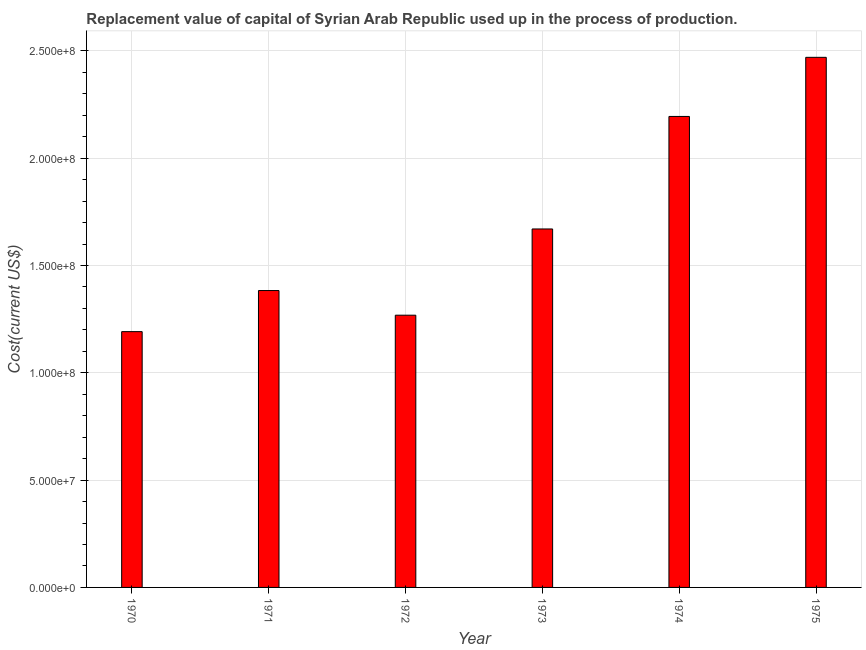Does the graph contain any zero values?
Give a very brief answer. No. Does the graph contain grids?
Provide a short and direct response. Yes. What is the title of the graph?
Provide a succinct answer. Replacement value of capital of Syrian Arab Republic used up in the process of production. What is the label or title of the X-axis?
Keep it short and to the point. Year. What is the label or title of the Y-axis?
Offer a very short reply. Cost(current US$). What is the consumption of fixed capital in 1972?
Make the answer very short. 1.27e+08. Across all years, what is the maximum consumption of fixed capital?
Your response must be concise. 2.47e+08. Across all years, what is the minimum consumption of fixed capital?
Provide a short and direct response. 1.19e+08. In which year was the consumption of fixed capital maximum?
Ensure brevity in your answer.  1975. In which year was the consumption of fixed capital minimum?
Offer a very short reply. 1970. What is the sum of the consumption of fixed capital?
Provide a succinct answer. 1.02e+09. What is the difference between the consumption of fixed capital in 1972 and 1975?
Provide a short and direct response. -1.20e+08. What is the average consumption of fixed capital per year?
Your answer should be very brief. 1.70e+08. What is the median consumption of fixed capital?
Your response must be concise. 1.53e+08. In how many years, is the consumption of fixed capital greater than 130000000 US$?
Offer a very short reply. 4. Do a majority of the years between 1975 and 1972 (inclusive) have consumption of fixed capital greater than 240000000 US$?
Keep it short and to the point. Yes. What is the ratio of the consumption of fixed capital in 1973 to that in 1975?
Ensure brevity in your answer.  0.68. Is the consumption of fixed capital in 1971 less than that in 1975?
Keep it short and to the point. Yes. What is the difference between the highest and the second highest consumption of fixed capital?
Keep it short and to the point. 2.75e+07. What is the difference between the highest and the lowest consumption of fixed capital?
Make the answer very short. 1.28e+08. In how many years, is the consumption of fixed capital greater than the average consumption of fixed capital taken over all years?
Provide a short and direct response. 2. How many bars are there?
Provide a succinct answer. 6. How many years are there in the graph?
Offer a very short reply. 6. What is the difference between two consecutive major ticks on the Y-axis?
Your answer should be compact. 5.00e+07. What is the Cost(current US$) of 1970?
Ensure brevity in your answer.  1.19e+08. What is the Cost(current US$) in 1971?
Your answer should be very brief. 1.38e+08. What is the Cost(current US$) of 1972?
Provide a succinct answer. 1.27e+08. What is the Cost(current US$) in 1973?
Your answer should be very brief. 1.67e+08. What is the Cost(current US$) in 1974?
Ensure brevity in your answer.  2.19e+08. What is the Cost(current US$) of 1975?
Provide a succinct answer. 2.47e+08. What is the difference between the Cost(current US$) in 1970 and 1971?
Provide a succinct answer. -1.91e+07. What is the difference between the Cost(current US$) in 1970 and 1972?
Give a very brief answer. -7.66e+06. What is the difference between the Cost(current US$) in 1970 and 1973?
Offer a very short reply. -4.78e+07. What is the difference between the Cost(current US$) in 1970 and 1974?
Your answer should be compact. -1.00e+08. What is the difference between the Cost(current US$) in 1970 and 1975?
Offer a terse response. -1.28e+08. What is the difference between the Cost(current US$) in 1971 and 1972?
Keep it short and to the point. 1.15e+07. What is the difference between the Cost(current US$) in 1971 and 1973?
Make the answer very short. -2.87e+07. What is the difference between the Cost(current US$) in 1971 and 1974?
Make the answer very short. -8.11e+07. What is the difference between the Cost(current US$) in 1971 and 1975?
Ensure brevity in your answer.  -1.09e+08. What is the difference between the Cost(current US$) in 1972 and 1973?
Make the answer very short. -4.02e+07. What is the difference between the Cost(current US$) in 1972 and 1974?
Your answer should be compact. -9.26e+07. What is the difference between the Cost(current US$) in 1972 and 1975?
Your answer should be very brief. -1.20e+08. What is the difference between the Cost(current US$) in 1973 and 1974?
Provide a succinct answer. -5.24e+07. What is the difference between the Cost(current US$) in 1973 and 1975?
Your response must be concise. -8.00e+07. What is the difference between the Cost(current US$) in 1974 and 1975?
Your answer should be compact. -2.75e+07. What is the ratio of the Cost(current US$) in 1970 to that in 1971?
Provide a succinct answer. 0.86. What is the ratio of the Cost(current US$) in 1970 to that in 1972?
Your answer should be very brief. 0.94. What is the ratio of the Cost(current US$) in 1970 to that in 1973?
Your response must be concise. 0.71. What is the ratio of the Cost(current US$) in 1970 to that in 1974?
Provide a succinct answer. 0.54. What is the ratio of the Cost(current US$) in 1970 to that in 1975?
Give a very brief answer. 0.48. What is the ratio of the Cost(current US$) in 1971 to that in 1972?
Ensure brevity in your answer.  1.09. What is the ratio of the Cost(current US$) in 1971 to that in 1973?
Your answer should be very brief. 0.83. What is the ratio of the Cost(current US$) in 1971 to that in 1974?
Offer a very short reply. 0.63. What is the ratio of the Cost(current US$) in 1971 to that in 1975?
Offer a terse response. 0.56. What is the ratio of the Cost(current US$) in 1972 to that in 1973?
Make the answer very short. 0.76. What is the ratio of the Cost(current US$) in 1972 to that in 1974?
Make the answer very short. 0.58. What is the ratio of the Cost(current US$) in 1972 to that in 1975?
Make the answer very short. 0.51. What is the ratio of the Cost(current US$) in 1973 to that in 1974?
Make the answer very short. 0.76. What is the ratio of the Cost(current US$) in 1973 to that in 1975?
Offer a terse response. 0.68. What is the ratio of the Cost(current US$) in 1974 to that in 1975?
Give a very brief answer. 0.89. 